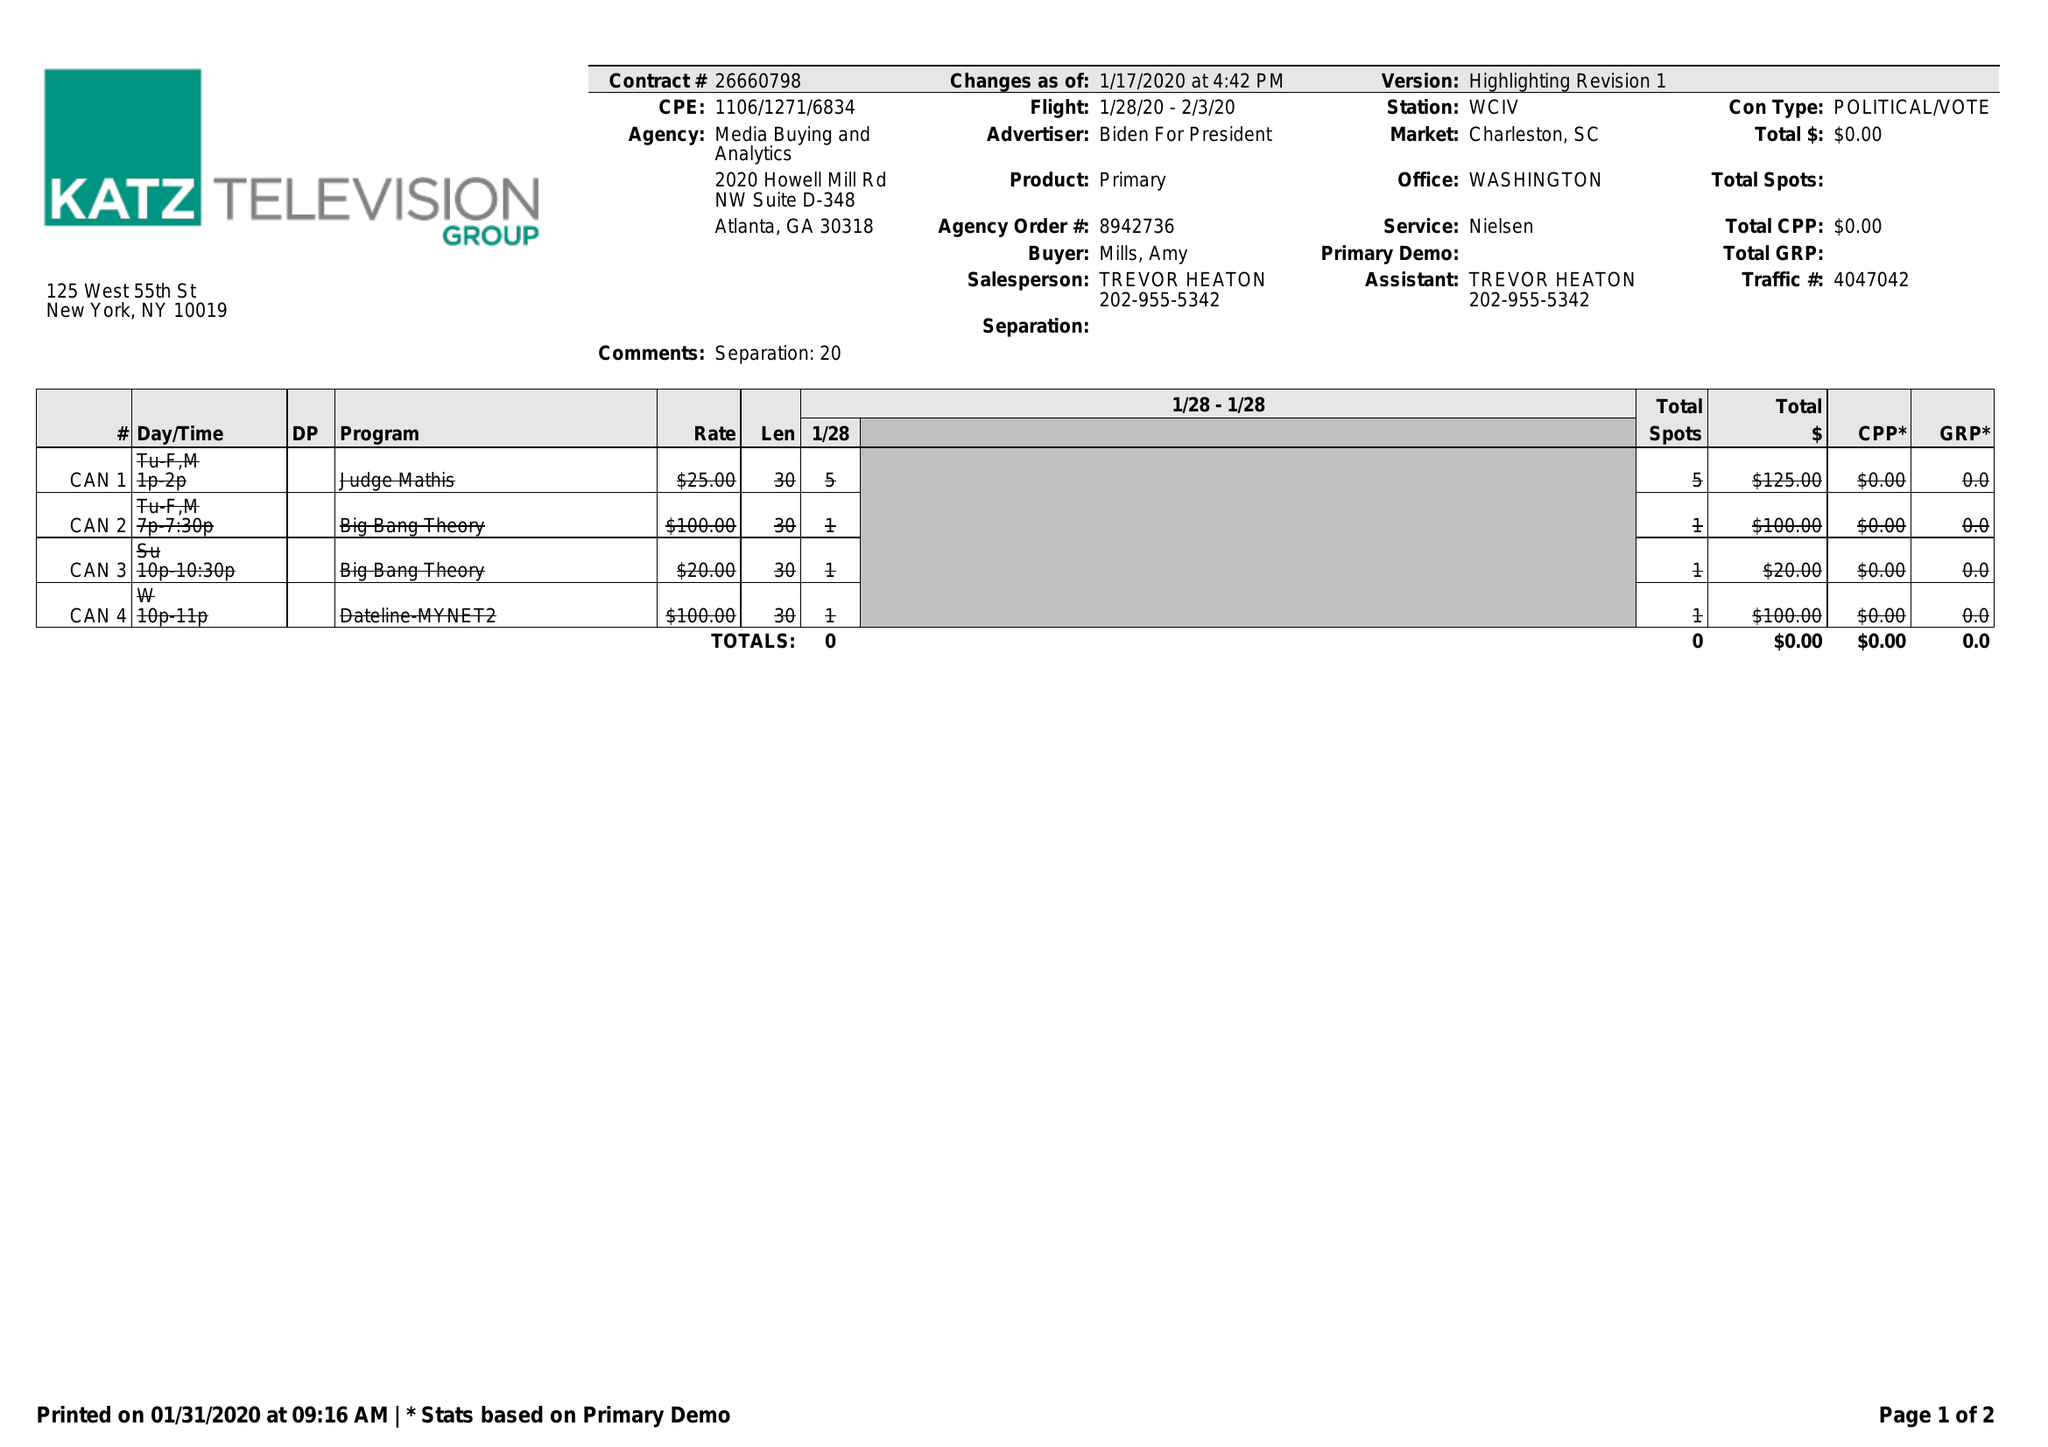What is the value for the advertiser?
Answer the question using a single word or phrase. BIDEN FOR PRESIDENT 